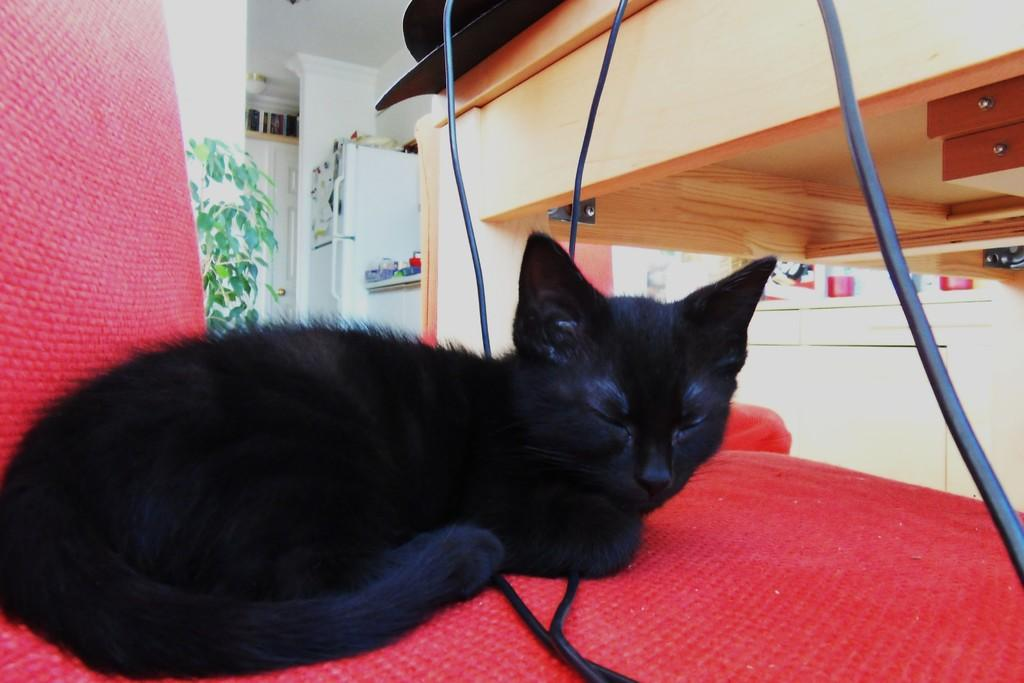What animal is present in the image? There is a cat in the image. Where is the cat located? The cat is sitting on a chair. What object is in front of the cat? There is a table in front of the cat. What can be seen in the background of the image? There is a refrigerator and a plant in the background of the image. What type of treatment is the cat receiving from its mother in the image? There is no indication in the image that the cat is receiving any treatment or that its mother is present. 